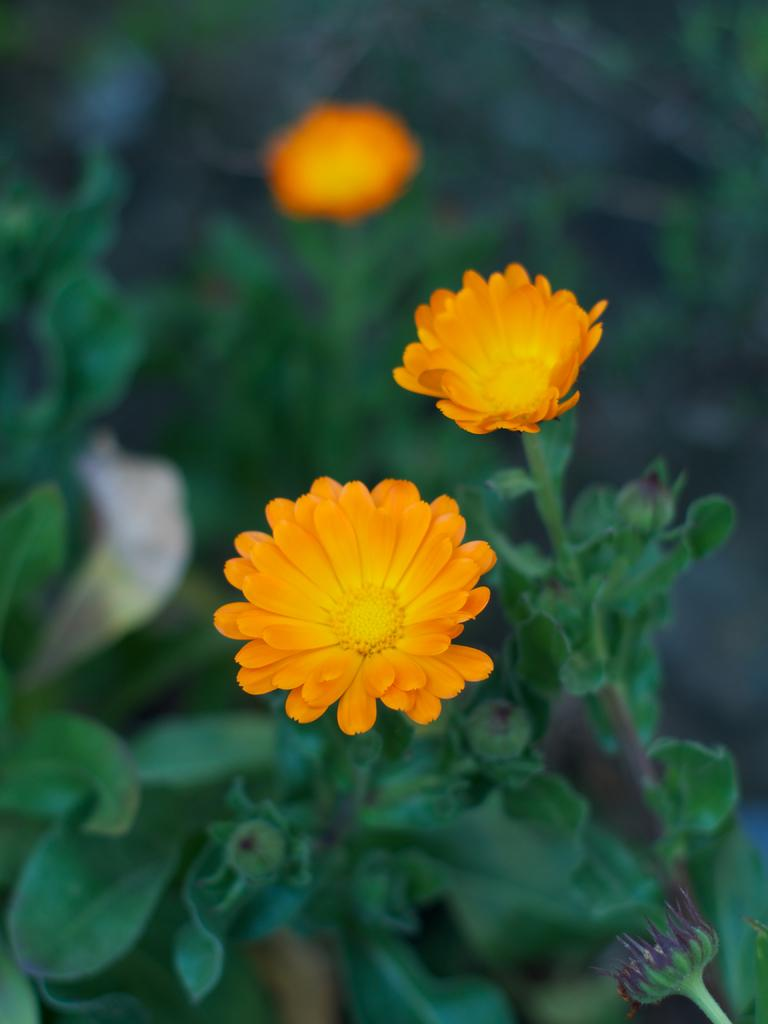What color are the flowers in the image? The flowers in the image are orange. What stage of growth are the plants in the image? The plants in the image have buds, indicating that they are in the process of blooming. What type of sand can be seen in the image? There is no sand present in the image; it features orange color flowers and plants with buds. How many bottles are visible in the image? There are no bottles present in the image. 